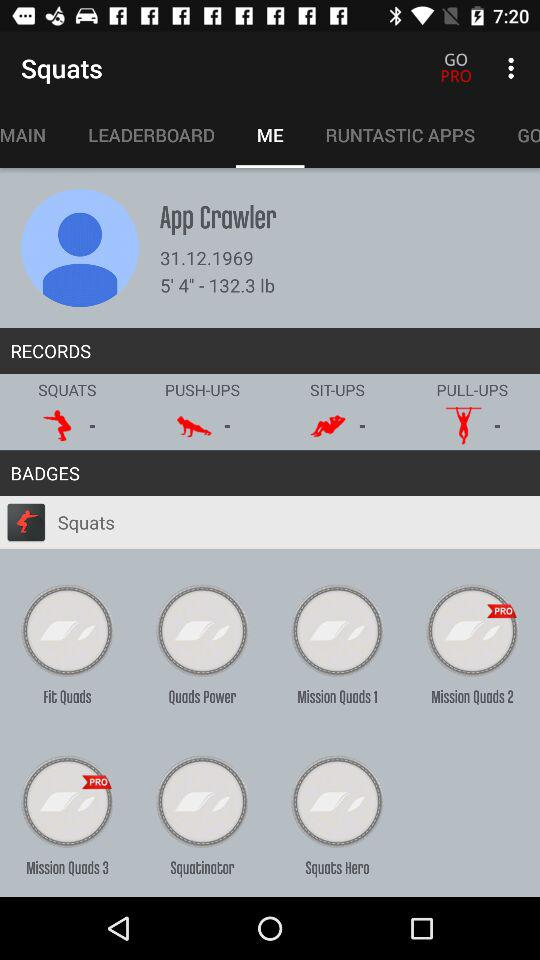What's the date of birth of the user? The date of birth of the user is December 31, 1969. 